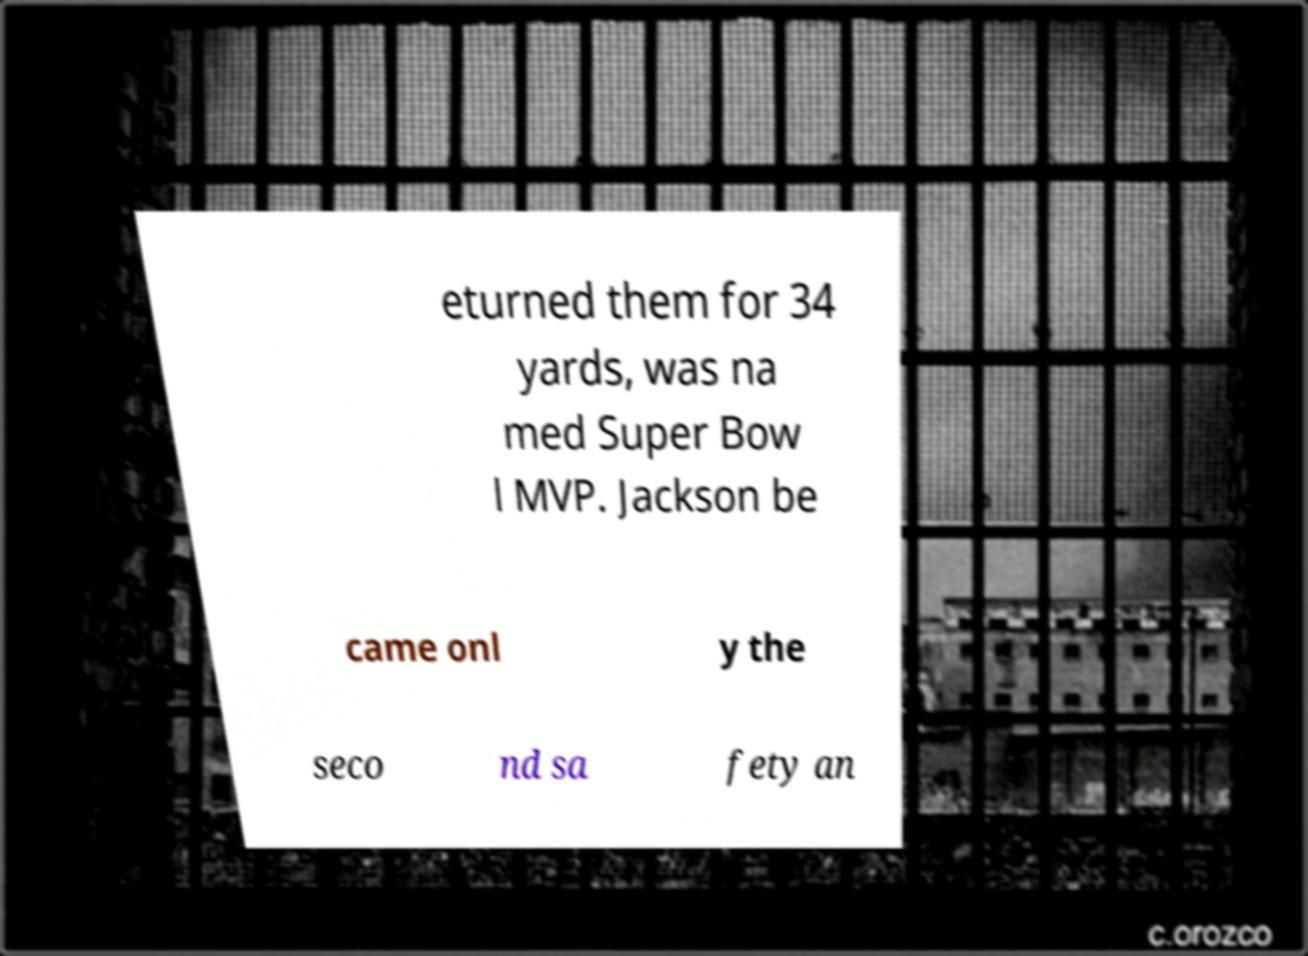There's text embedded in this image that I need extracted. Can you transcribe it verbatim? eturned them for 34 yards, was na med Super Bow l MVP. Jackson be came onl y the seco nd sa fety an 